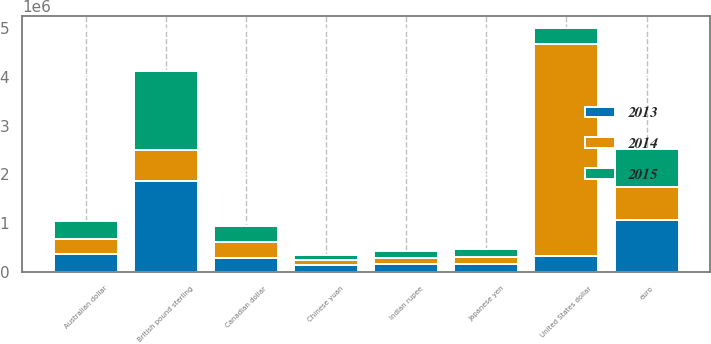Convert chart. <chart><loc_0><loc_0><loc_500><loc_500><stacked_bar_chart><ecel><fcel>United States dollar<fcel>British pound sterling<fcel>euro<fcel>Australian dollar<fcel>Canadian dollar<fcel>Indian rupee<fcel>Japanese yen<fcel>Chinese yuan<nl><fcel>2013<fcel>321231<fcel>1.8612e+06<fcel>1.07167e+06<fcel>360284<fcel>291273<fcel>171678<fcel>155842<fcel>152771<nl><fcel>2015<fcel>321231<fcel>1.63213e+06<fcel>773753<fcel>359660<fcel>319670<fcel>135139<fcel>168574<fcel>101790<nl><fcel>2014<fcel>4.35928e+06<fcel>634375<fcel>677258<fcel>322792<fcel>324900<fcel>118944<fcel>151050<fcel>102643<nl></chart> 